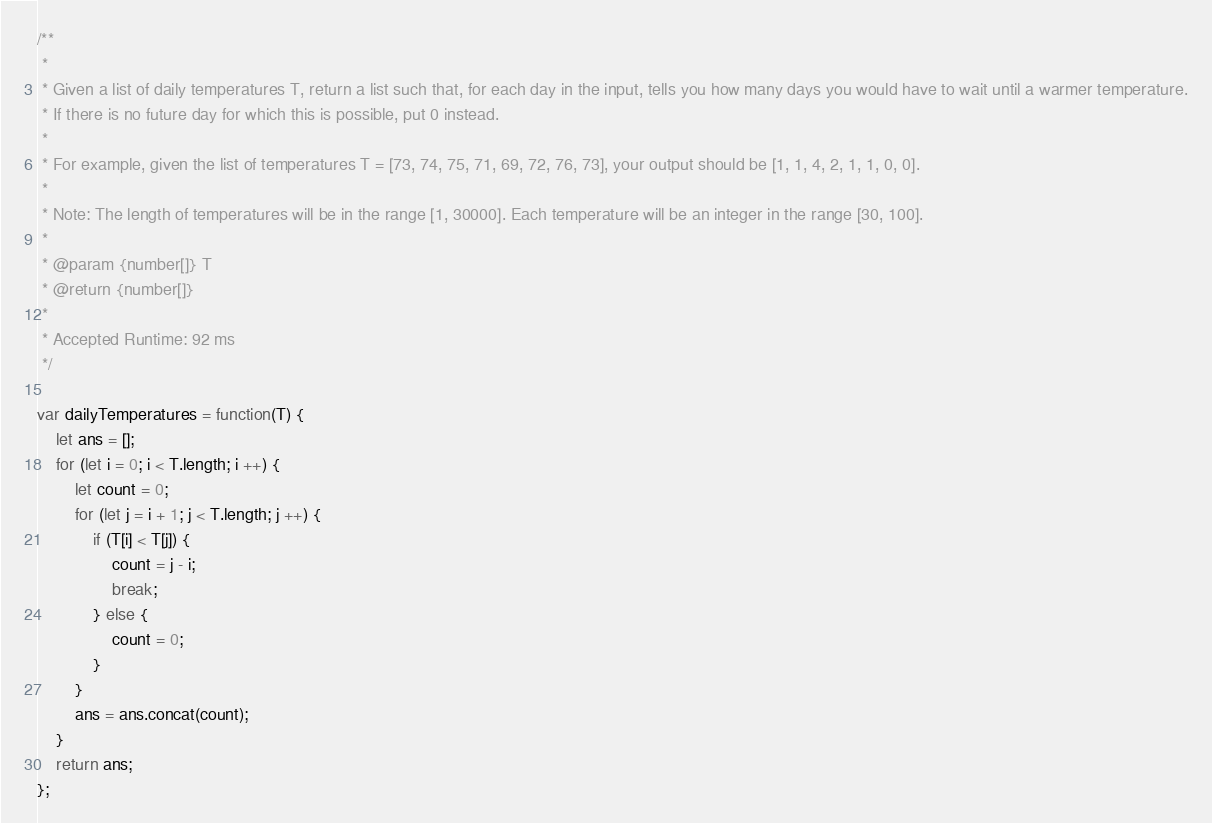<code> <loc_0><loc_0><loc_500><loc_500><_JavaScript_>/**
 * 
 * Given a list of daily temperatures T, return a list such that, for each day in the input, tells you how many days you would have to wait until a warmer temperature.
 * If there is no future day for which this is possible, put 0 instead.
 * 
 * For example, given the list of temperatures T = [73, 74, 75, 71, 69, 72, 76, 73], your output should be [1, 1, 4, 2, 1, 1, 0, 0].
 * 
 * Note: The length of temperatures will be in the range [1, 30000]. Each temperature will be an integer in the range [30, 100].
 * 
 * @param {number[]} T
 * @return {number[]}
 * 
 * Accepted Runtime: 92 ms
 */

var dailyTemperatures = function(T) {
    let ans = [];
    for (let i = 0; i < T.length; i ++) {
        let count = 0;
        for (let j = i + 1; j < T.length; j ++) {
            if (T[i] < T[j]) {
                count = j - i;
                break;
            } else {
                count = 0;
            }
        }
        ans = ans.concat(count);
    }
    return ans;
};</code> 